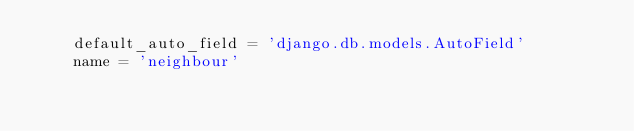Convert code to text. <code><loc_0><loc_0><loc_500><loc_500><_Python_>    default_auto_field = 'django.db.models.AutoField'
    name = 'neighbour'
</code> 